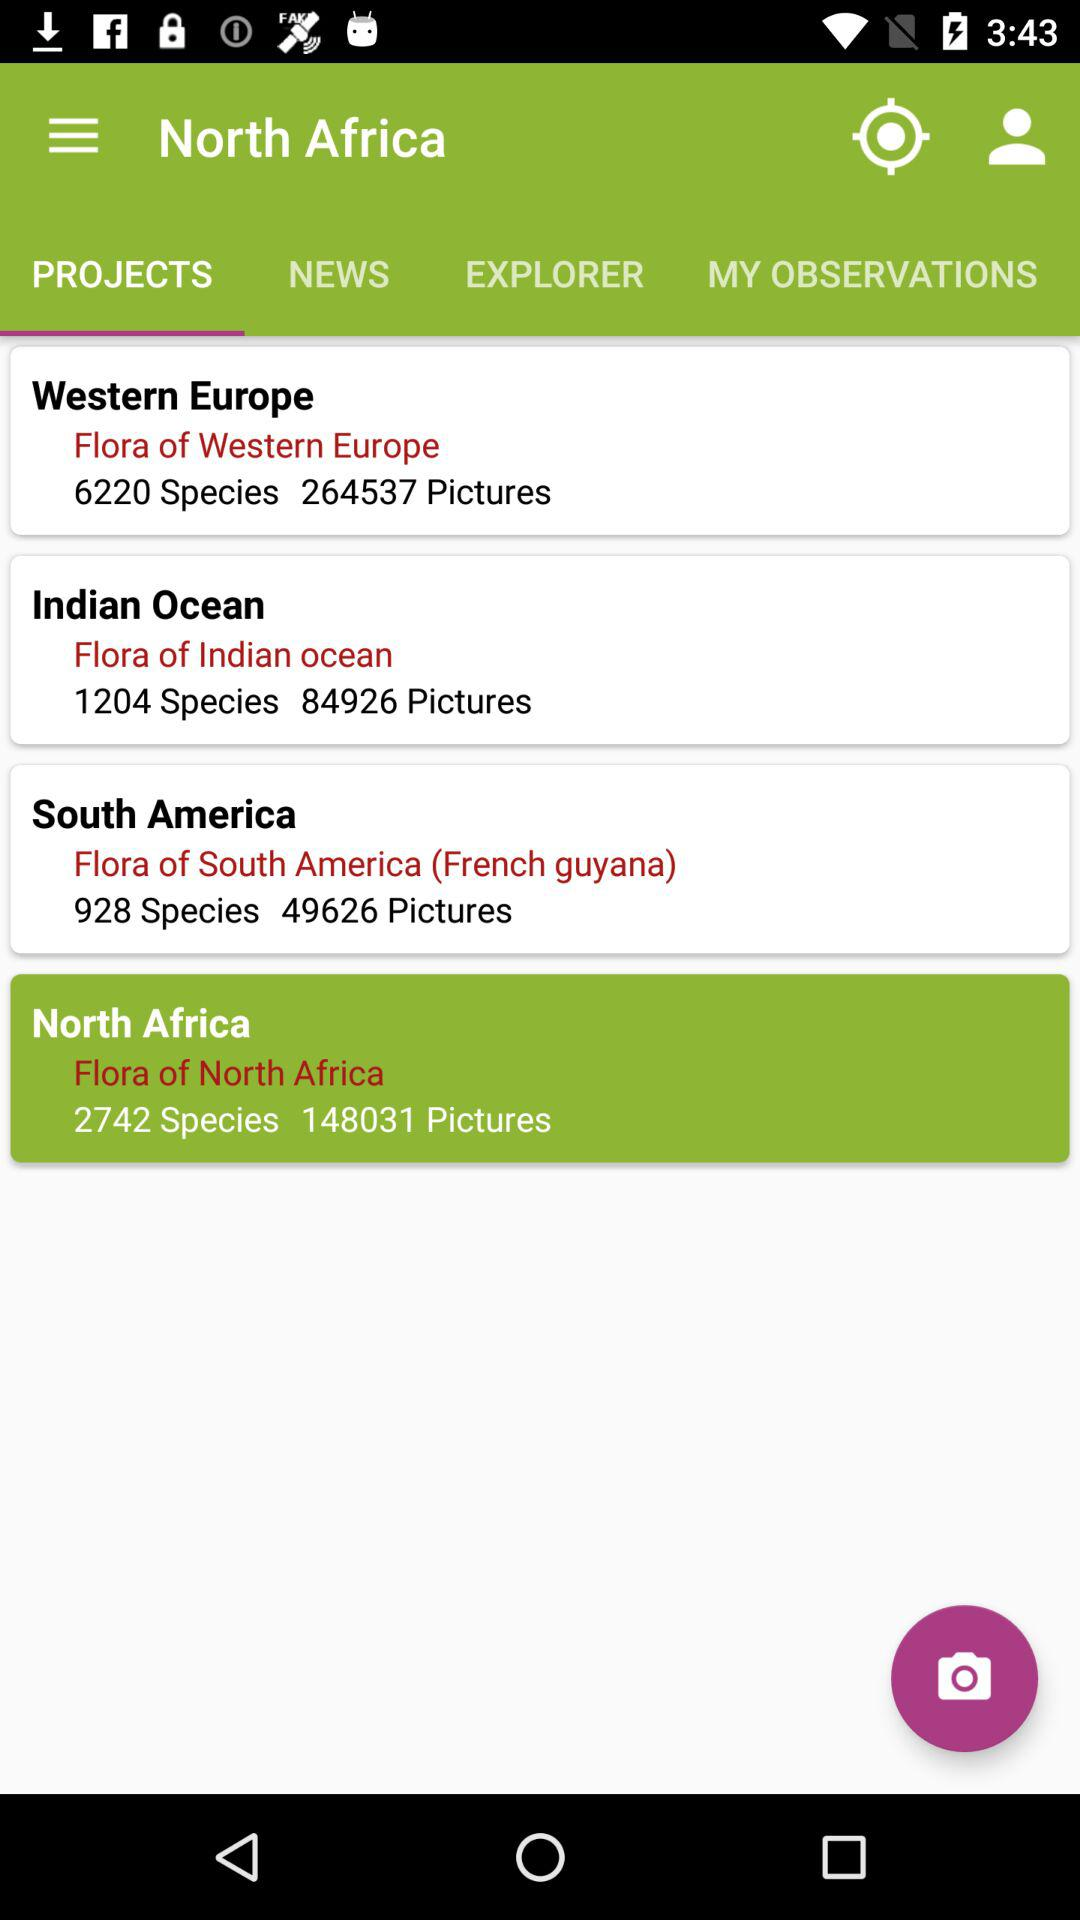How many pictures are there in "Flora of Western Europe"? There are 264537 pictures in "Flora of Western Europe". 